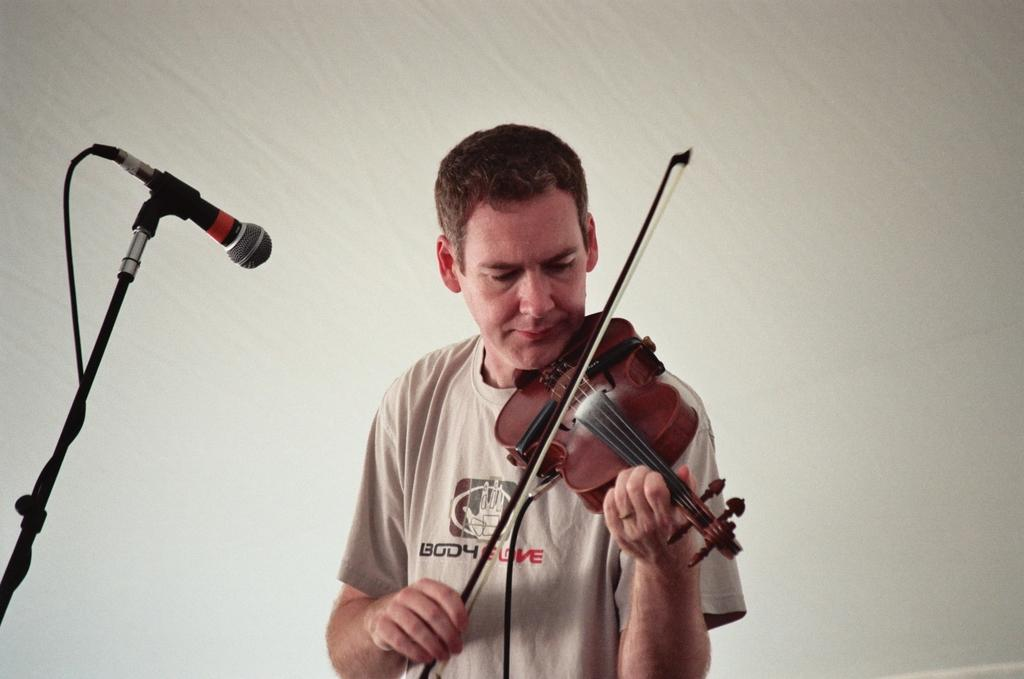What is the man in the image holding? The man is holding a guitar. Can you describe any other objects or features in the image? Yes, there is a microphone on the left side of the image. Can you see any chickens or robins in the image? No, there are no chickens or robins present in the image. What is the man pointing at in the image? The image does not show the man pointing at anything. 